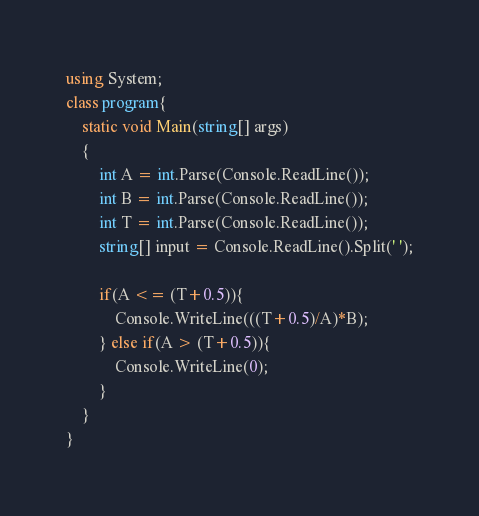Convert code to text. <code><loc_0><loc_0><loc_500><loc_500><_C#_>using System;
class program{
    static void Main(string[] args)
    {
        int A = int.Parse(Console.ReadLine());
        int B = int.Parse(Console.ReadLine());
        int T = int.Parse(Console.ReadLine());
        string[] input = Console.ReadLine().Split(' ');
        
        if(A <= (T+0.5)){
            Console.WriteLine(((T+0.5)/A)*B);
        } else if(A > (T+0.5)){
            Console.WriteLine(0);
        }
    }
}</code> 